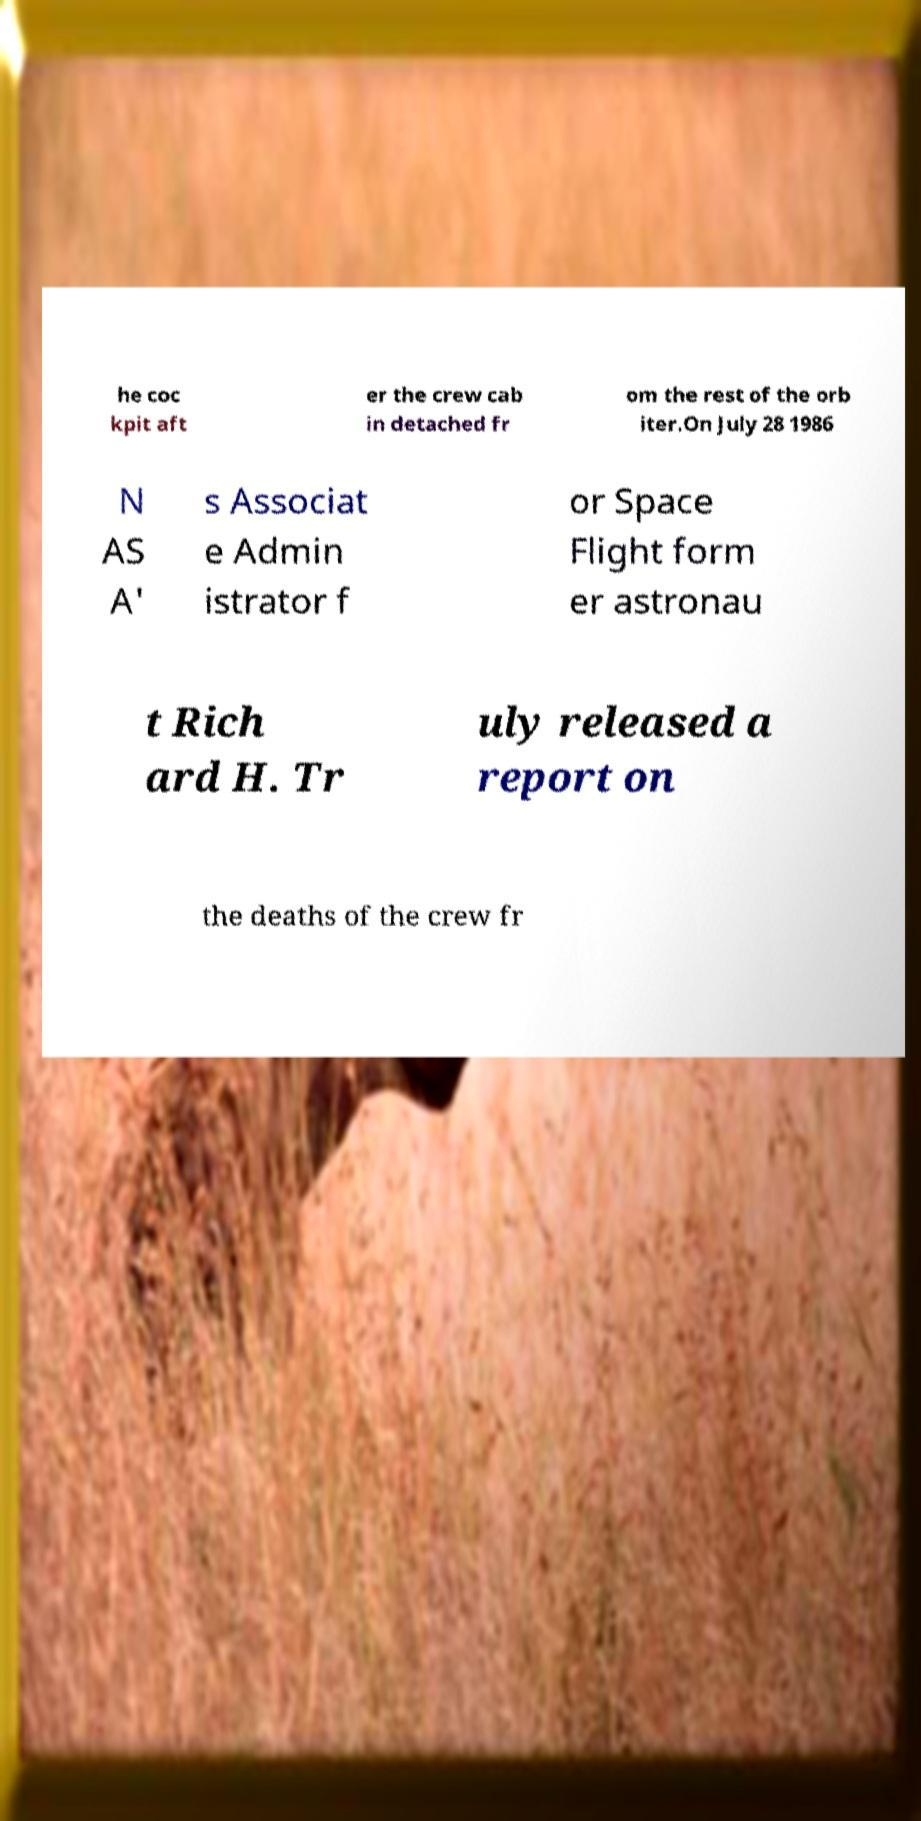What messages or text are displayed in this image? I need them in a readable, typed format. he coc kpit aft er the crew cab in detached fr om the rest of the orb iter.On July 28 1986 N AS A' s Associat e Admin istrator f or Space Flight form er astronau t Rich ard H. Tr uly released a report on the deaths of the crew fr 